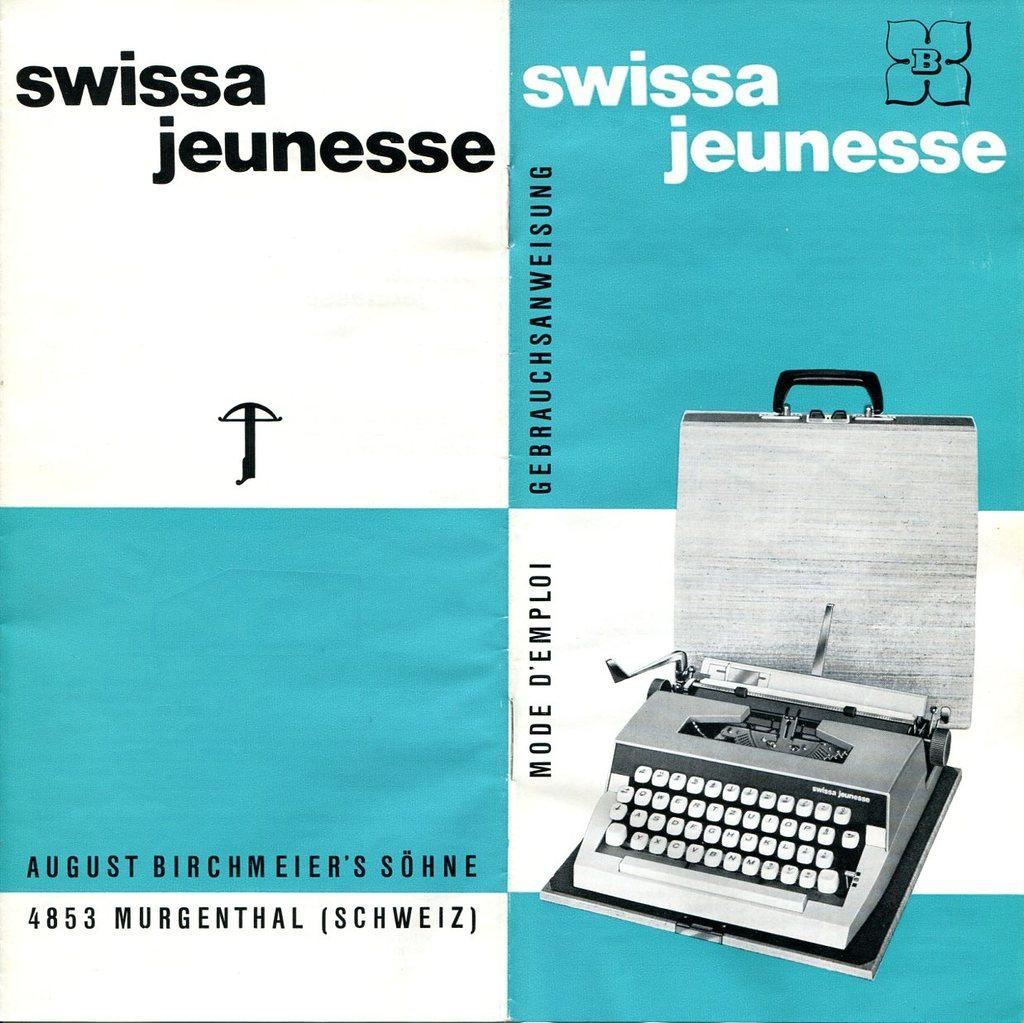<image>
Present a compact description of the photo's key features. A picture for Swissa Jeunesse branded typewriter in white and blure. 